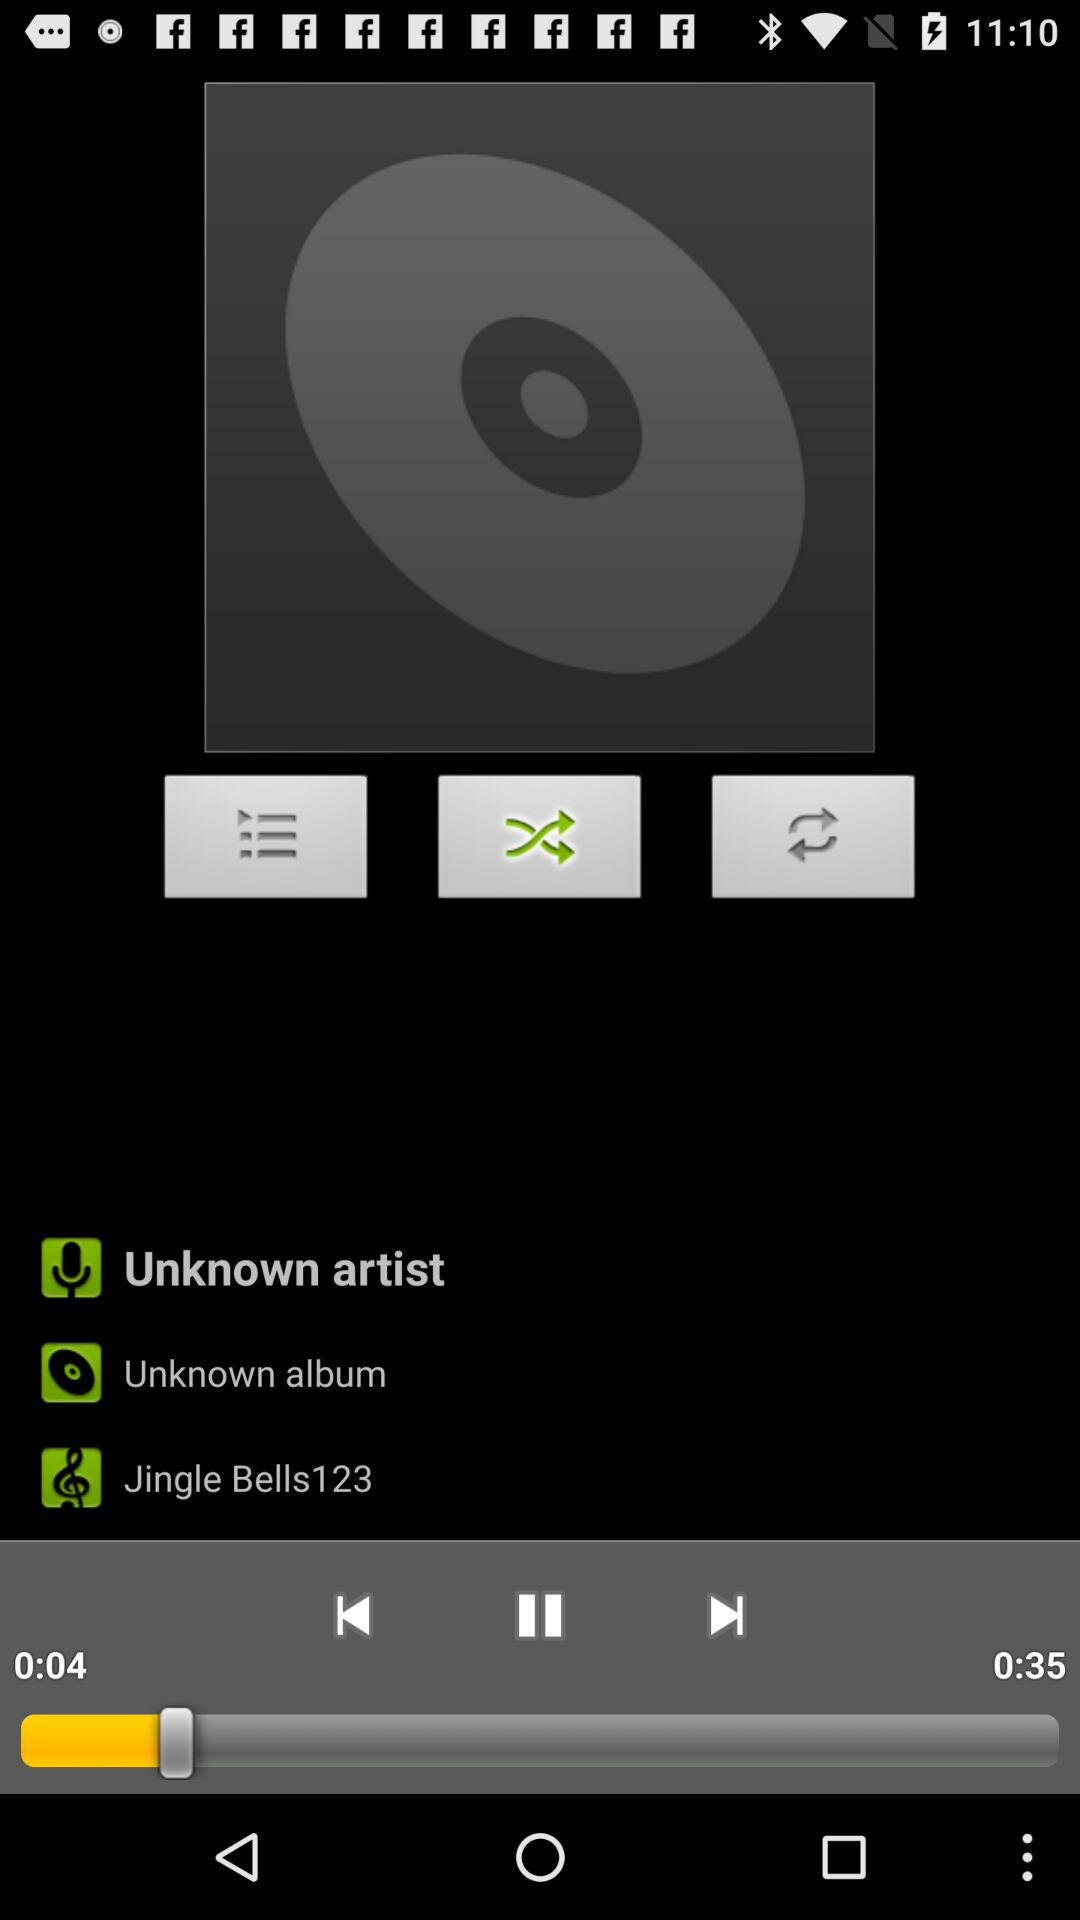Who is the singer? The singer is unknown. 